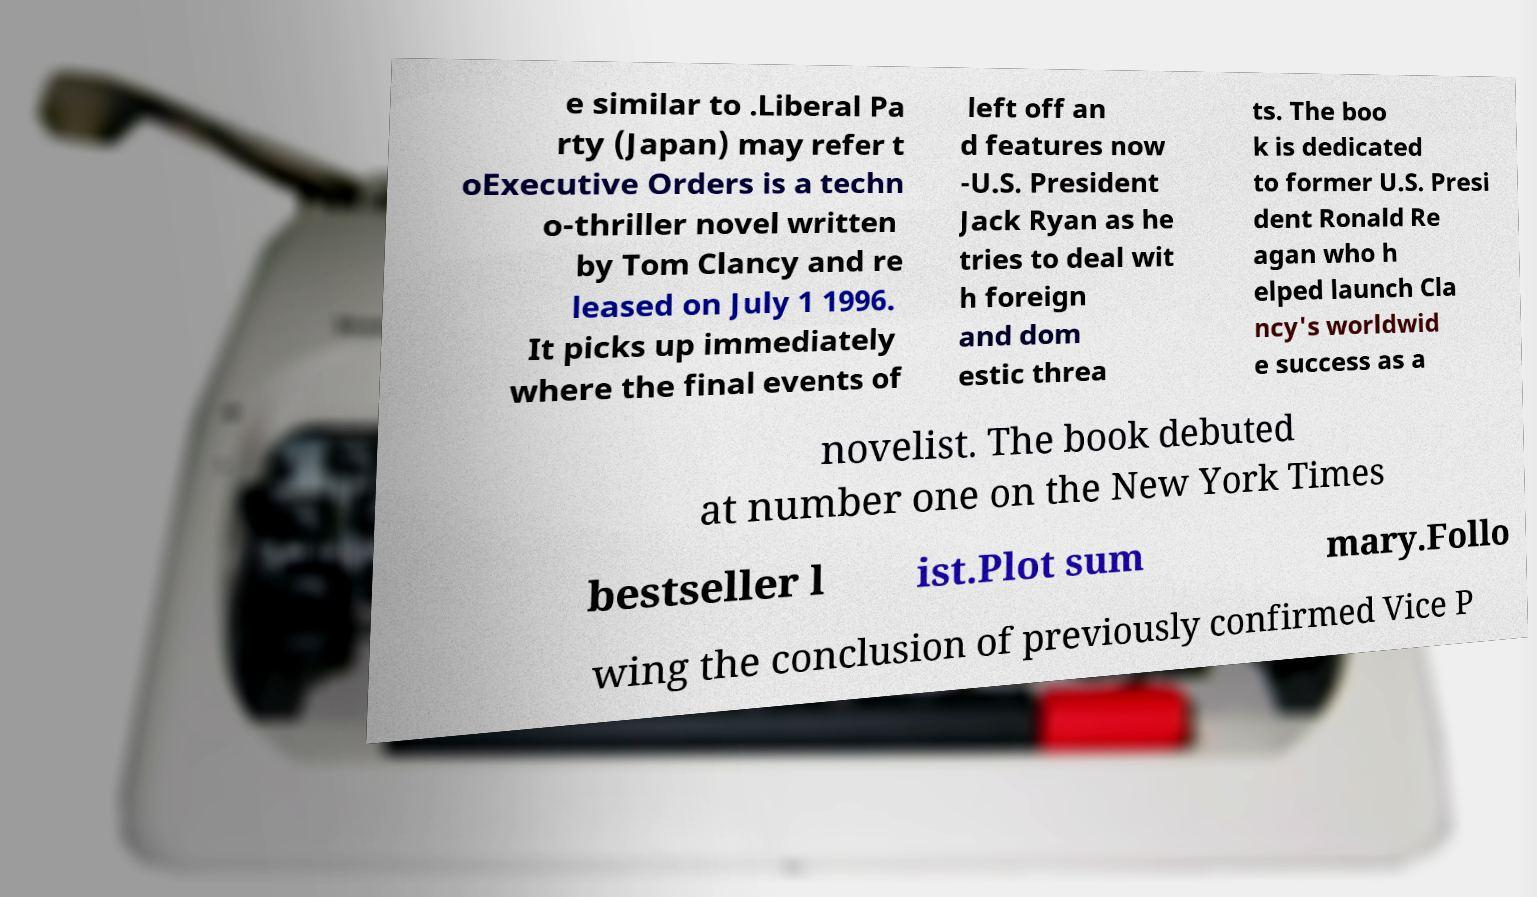Can you accurately transcribe the text from the provided image for me? e similar to .Liberal Pa rty (Japan) may refer t oExecutive Orders is a techn o-thriller novel written by Tom Clancy and re leased on July 1 1996. It picks up immediately where the final events of left off an d features now -U.S. President Jack Ryan as he tries to deal wit h foreign and dom estic threa ts. The boo k is dedicated to former U.S. Presi dent Ronald Re agan who h elped launch Cla ncy's worldwid e success as a novelist. The book debuted at number one on the New York Times bestseller l ist.Plot sum mary.Follo wing the conclusion of previously confirmed Vice P 